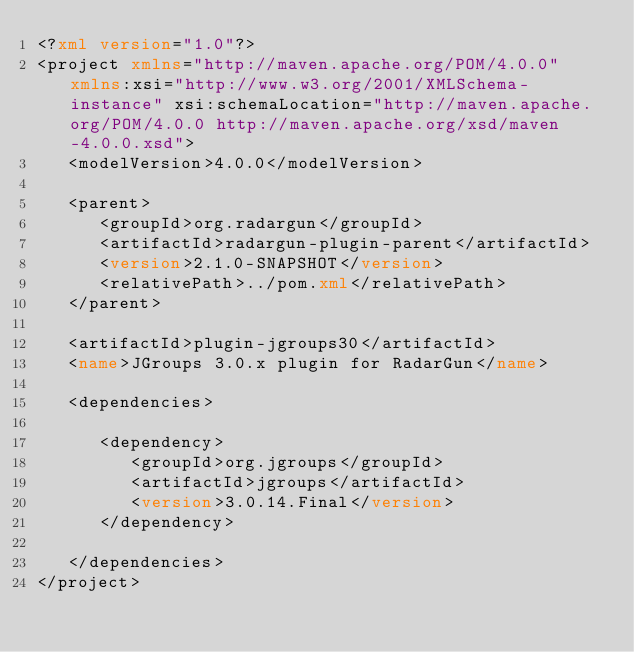<code> <loc_0><loc_0><loc_500><loc_500><_XML_><?xml version="1.0"?>
<project xmlns="http://maven.apache.org/POM/4.0.0" xmlns:xsi="http://www.w3.org/2001/XMLSchema-instance" xsi:schemaLocation="http://maven.apache.org/POM/4.0.0 http://maven.apache.org/xsd/maven-4.0.0.xsd">
   <modelVersion>4.0.0</modelVersion>

   <parent>
      <groupId>org.radargun</groupId>
      <artifactId>radargun-plugin-parent</artifactId>
      <version>2.1.0-SNAPSHOT</version>
      <relativePath>../pom.xml</relativePath>
   </parent>

   <artifactId>plugin-jgroups30</artifactId>
   <name>JGroups 3.0.x plugin for RadarGun</name>

   <dependencies>

      <dependency>
         <groupId>org.jgroups</groupId>
         <artifactId>jgroups</artifactId>
         <version>3.0.14.Final</version>
      </dependency>

   </dependencies>
</project>
</code> 